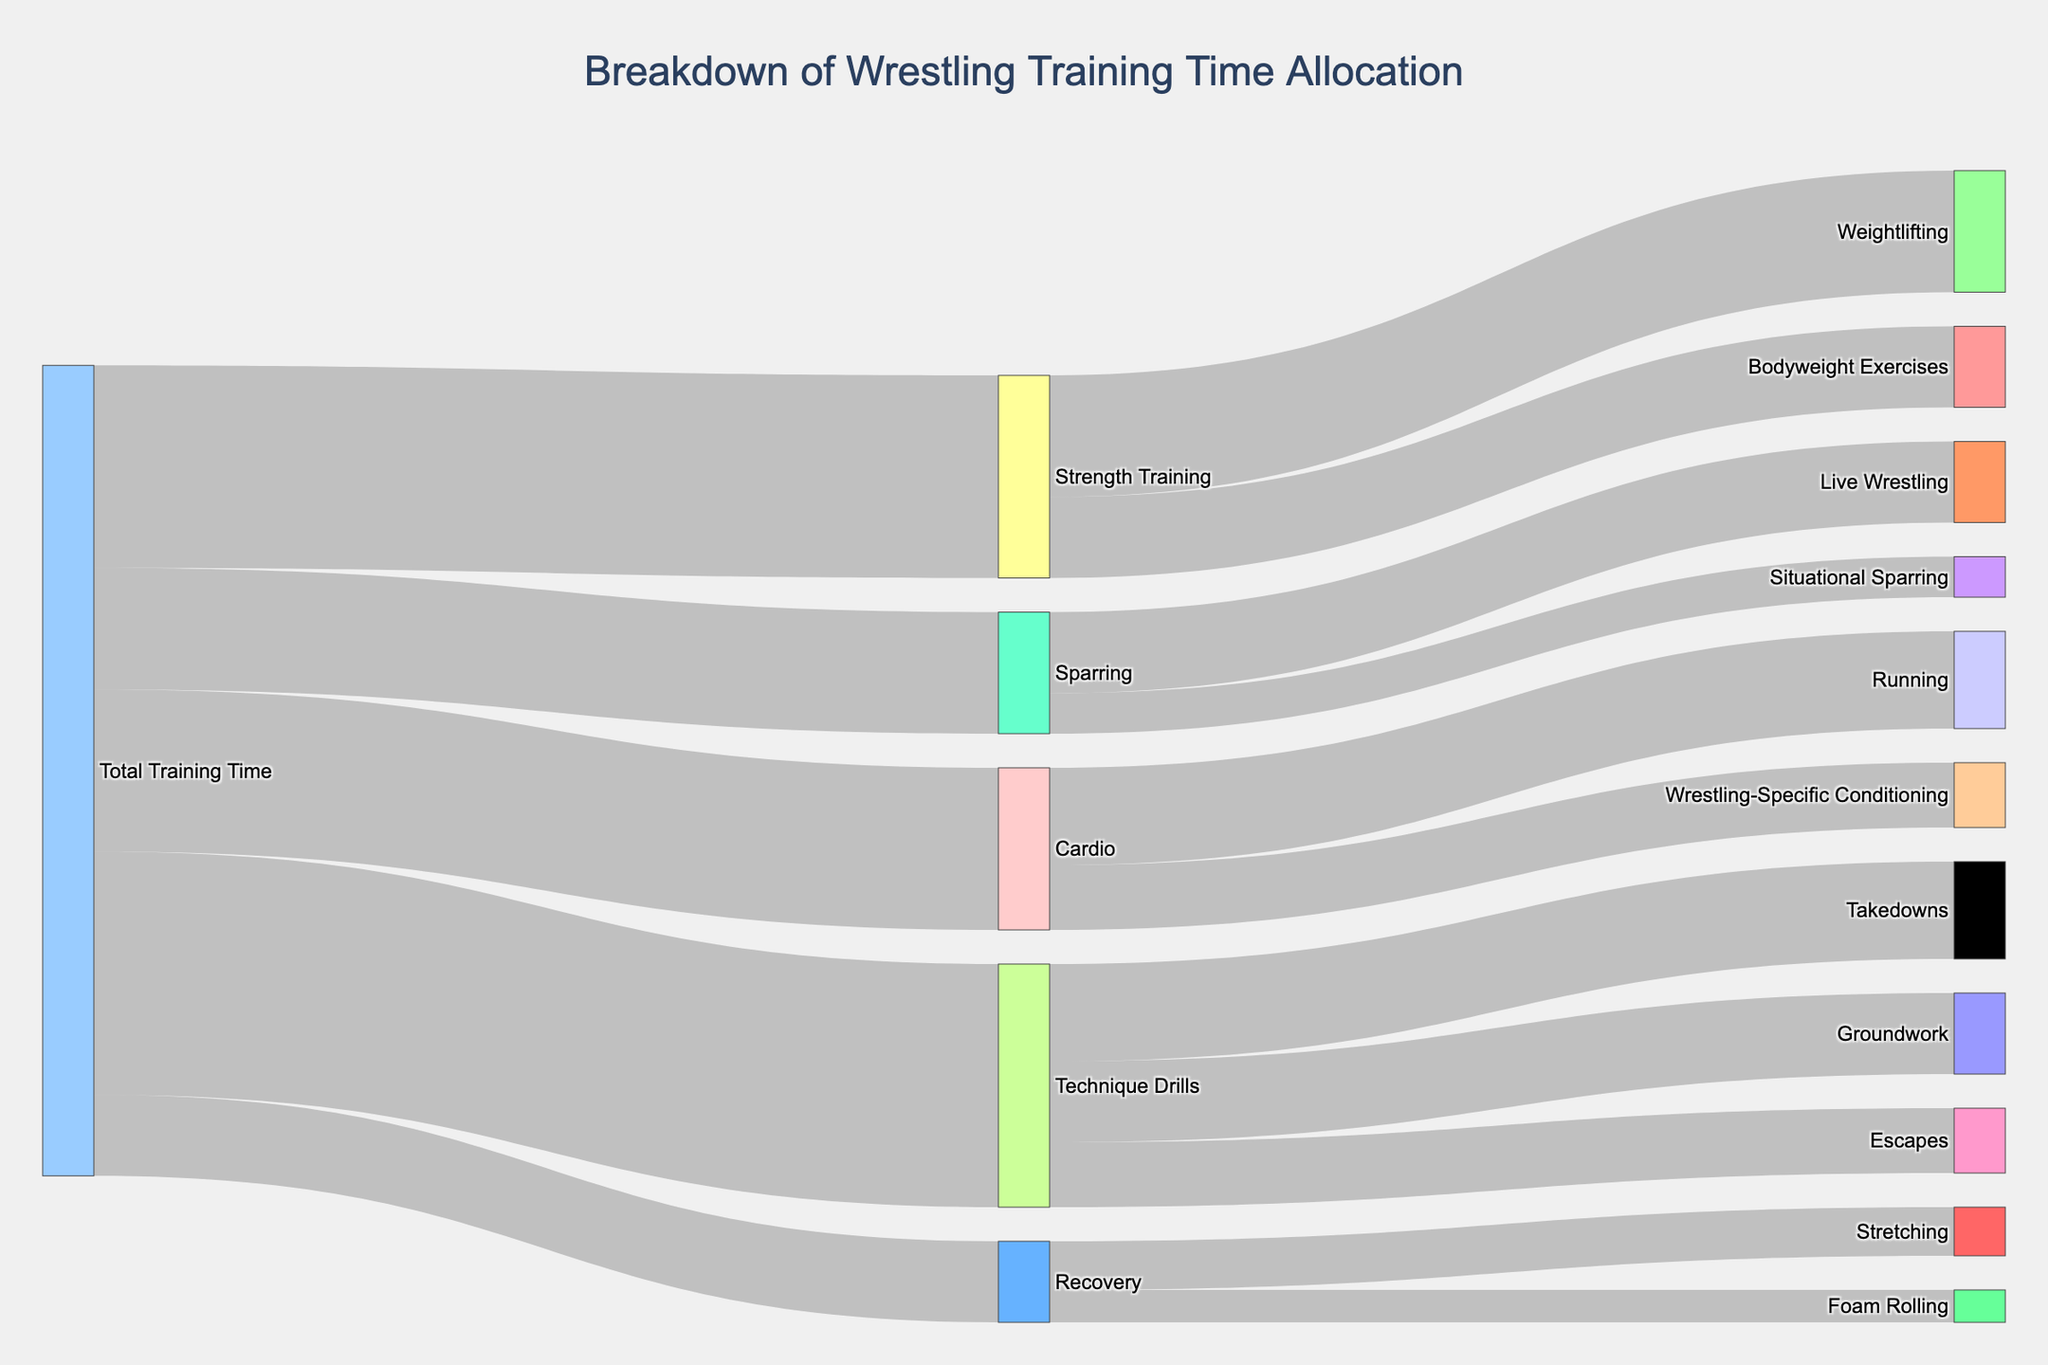How is the total training time distributed across different main activities? The main activities and their allocations can be observed from the first level of branches from "Total Training Time". Strength Training takes 25 units, Technique Drills 30 units, Cardio 20 units, Sparring 15 units, and Recovery 10 units.
Answer: Strength Training 25, Technique Drills 30, Cardio 20, Sparring 15, Recovery 10 Which activity under Strength Training gets the maximum allocation? Under Strength Training, the activities are Weightlifting and Bodyweight Exercises. Weightlifting has 15 units while Bodyweight Exercises has 10 units, making Weightlifting the maximum.
Answer: Weightlifting What is the combined time allocated for Takedowns and Escapes? The Technique Drills branch shows Takedowns with 12 units and Escapes with 8 units. Adding these gives 12 + 8 = 20 units.
Answer: 20 Which has more allocated time: Running or Wrestling-Specific Conditioning? Under Cardio, Running has 12 units, and Wrestling-Specific Conditioning has 8 units. Therefore, Running has more allocated time.
Answer: Running Compare the time allocated to Sparring activities versus Recovery activities. Sparring has Live Wrestling (10) and Situational Sparring (5), totaling 15 units. Recovery has Stretching (6) and Foam Rolling (4), totaling 10 units. Sparring activities have more time allocated.
Answer: Sparring What percentage of the total training time is allocated to Technique Drills? The total training time is 100 units. Technique Drills has 30 units. The percentage is (30/100) * 100 = 30%.
Answer: 30% How does the time allocated to Foam Rolling compare with Bodyweight Exercises? Foam Rolling under Recovery has 4 units, while Bodyweight Exercises under Strength Training has 10 units. Bodyweight Exercises has more time allocated.
Answer: Bodyweight Exercises Sum up the time allocated to all the activities involving some form of sparring. Live Wrestling has 10 units and Situational Sparring has 5 units. The total time for sparring activities sums to 10 + 5 = 15 units.
Answer: 15 Of all activities, which has the smallest allocation? Looking at all activities and their allocated times, Foam Rolling has the smallest with 4 units.
Answer: Foam Rolling 